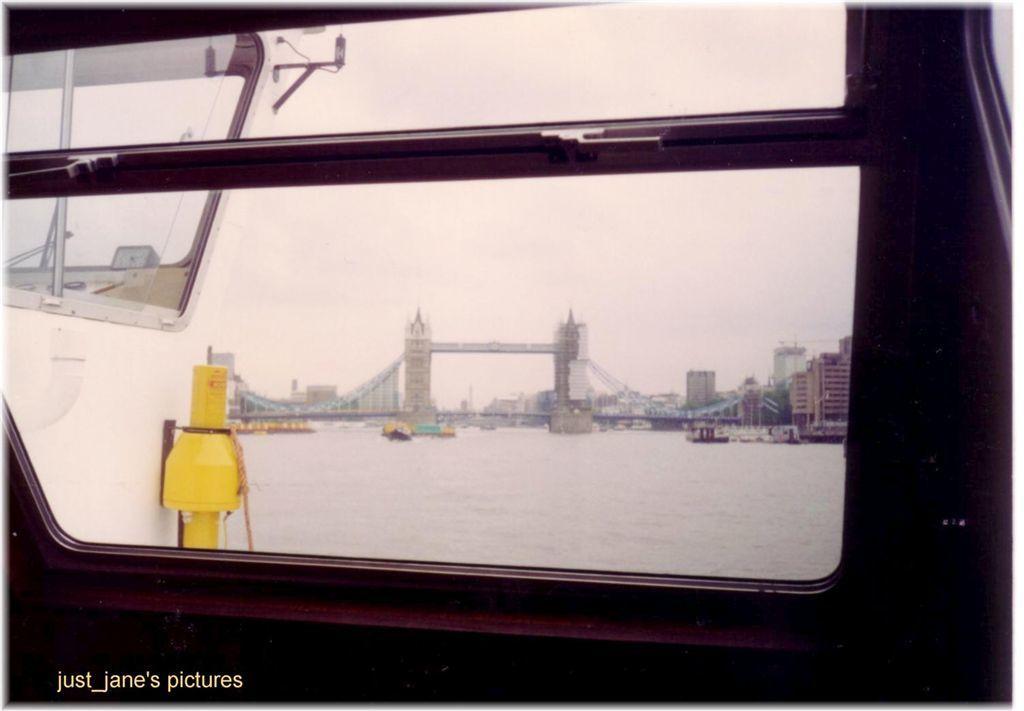How would you summarize this image in a sentence or two? There is a glass window at the bottom of this image. We can see a bridge, buildings, water and the sky is through this glass. 